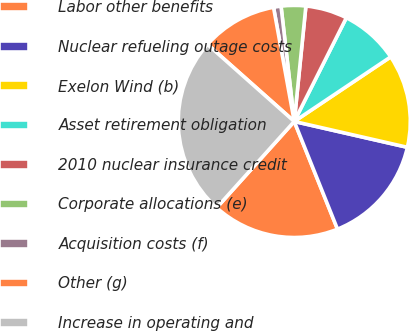Convert chart. <chart><loc_0><loc_0><loc_500><loc_500><pie_chart><fcel>Labor other benefits<fcel>Nuclear refueling outage costs<fcel>Exelon Wind (b)<fcel>Asset retirement obligation<fcel>2010 nuclear insurance credit<fcel>Corporate allocations (e)<fcel>Acquisition costs (f)<fcel>Other (g)<fcel>Increase in operating and<nl><fcel>17.74%<fcel>15.35%<fcel>12.97%<fcel>8.2%<fcel>5.81%<fcel>3.42%<fcel>1.04%<fcel>10.58%<fcel>24.9%<nl></chart> 